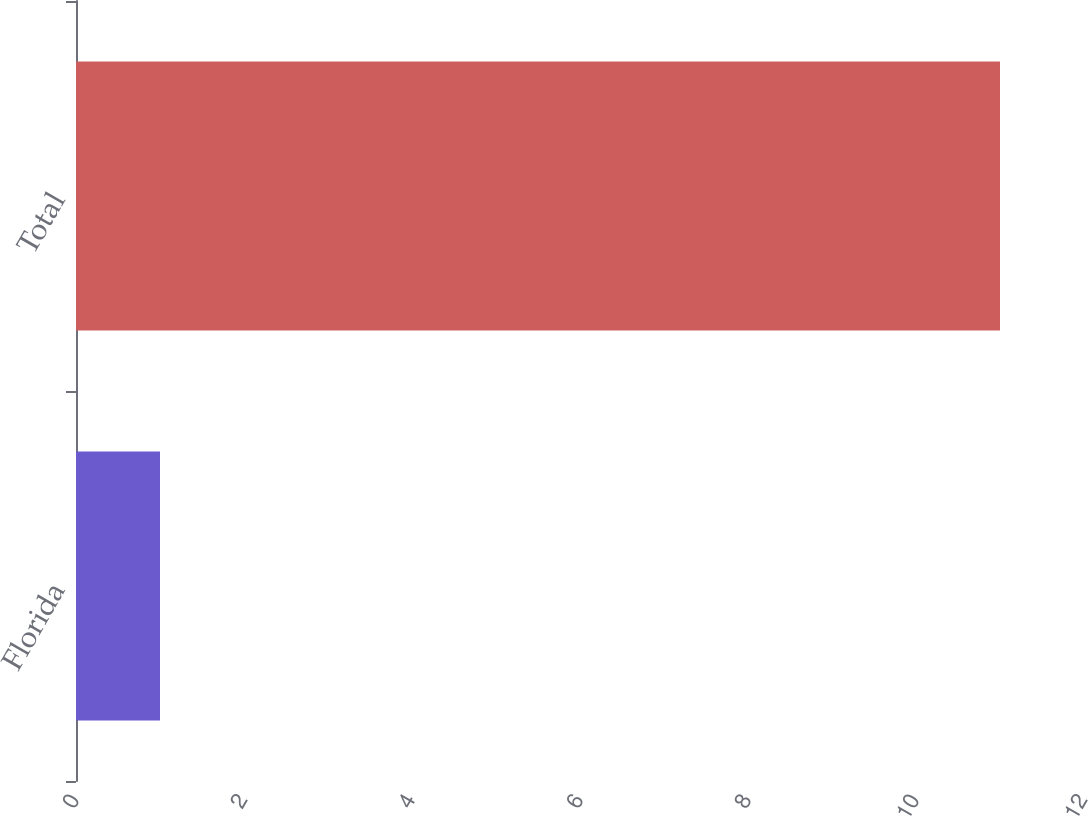Convert chart. <chart><loc_0><loc_0><loc_500><loc_500><bar_chart><fcel>Florida<fcel>Total<nl><fcel>1<fcel>11<nl></chart> 